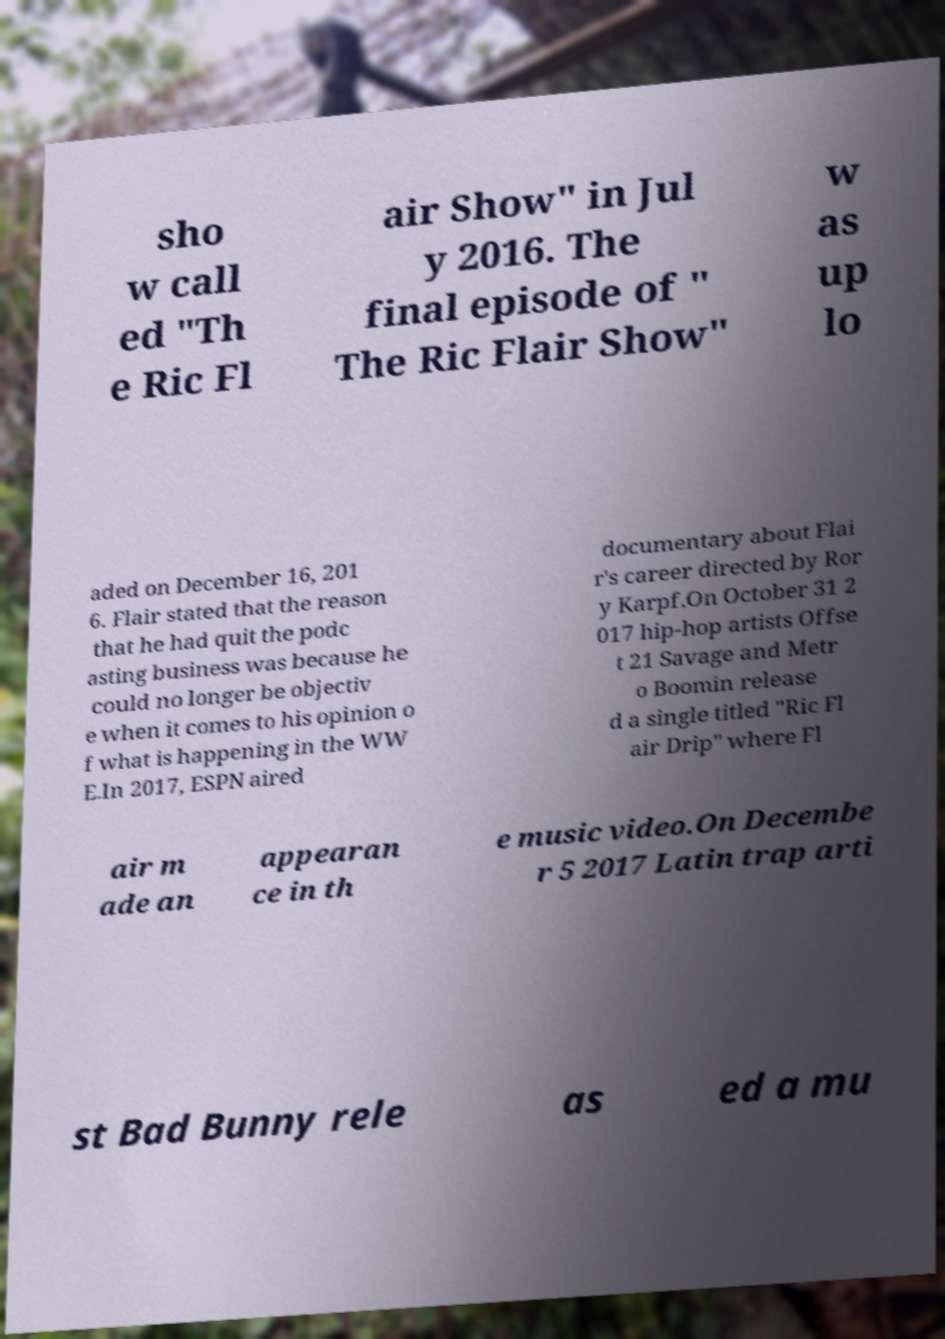Can you read and provide the text displayed in the image?This photo seems to have some interesting text. Can you extract and type it out for me? sho w call ed "Th e Ric Fl air Show" in Jul y 2016. The final episode of " The Ric Flair Show" w as up lo aded on December 16, 201 6. Flair stated that the reason that he had quit the podc asting business was because he could no longer be objectiv e when it comes to his opinion o f what is happening in the WW E.In 2017, ESPN aired documentary about Flai r's career directed by Ror y Karpf.On October 31 2 017 hip-hop artists Offse t 21 Savage and Metr o Boomin release d a single titled "Ric Fl air Drip" where Fl air m ade an appearan ce in th e music video.On Decembe r 5 2017 Latin trap arti st Bad Bunny rele as ed a mu 